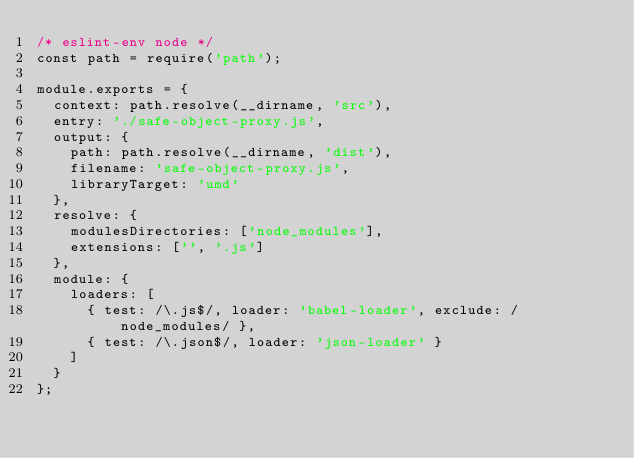Convert code to text. <code><loc_0><loc_0><loc_500><loc_500><_JavaScript_>/* eslint-env node */
const path = require('path');

module.exports = {
  context: path.resolve(__dirname, 'src'),
  entry: './safe-object-proxy.js',
  output: {
    path: path.resolve(__dirname, 'dist'),
    filename: 'safe-object-proxy.js',
    libraryTarget: 'umd'
  },
  resolve: {
    modulesDirectories: ['node_modules'],
    extensions: ['', '.js']
  },
  module: {
    loaders: [
      { test: /\.js$/, loader: 'babel-loader', exclude: /node_modules/ },
      { test: /\.json$/, loader: 'json-loader' }
    ]
  }
};
</code> 